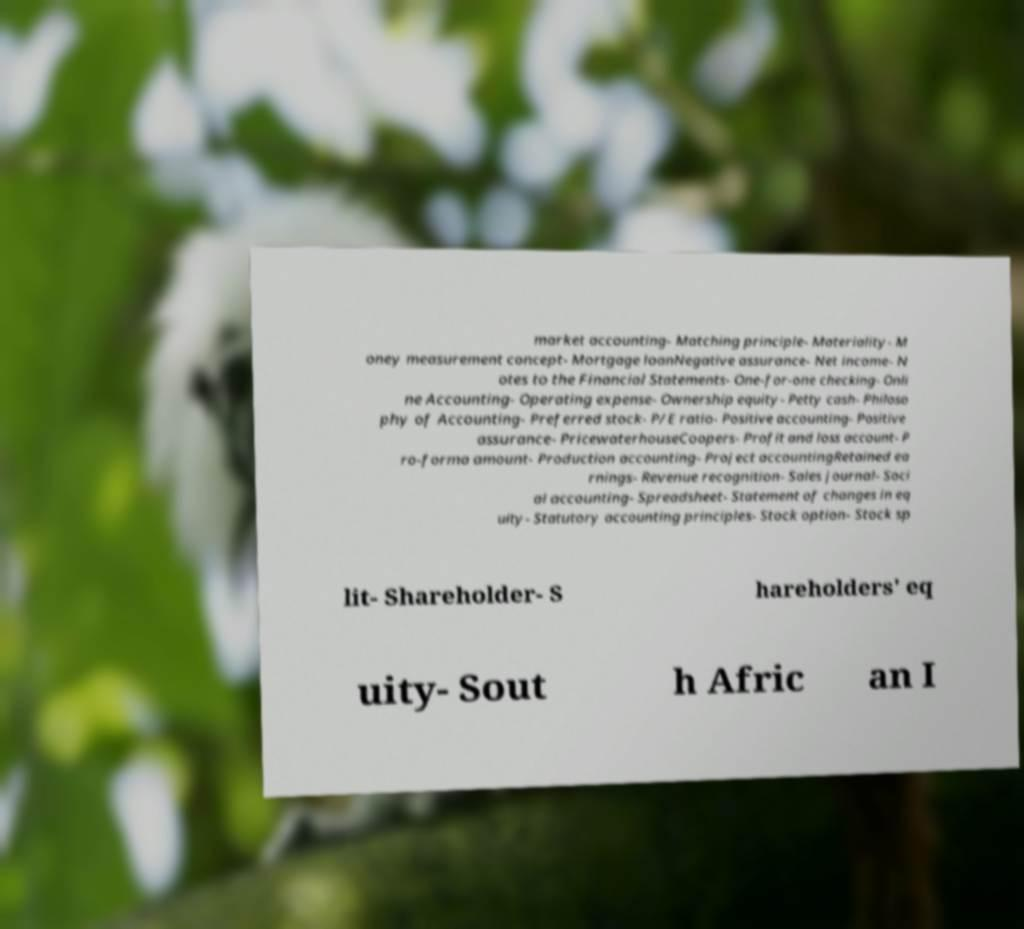I need the written content from this picture converted into text. Can you do that? market accounting- Matching principle- Materiality- M oney measurement concept- Mortgage loanNegative assurance- Net income- N otes to the Financial Statements- One-for-one checking- Onli ne Accounting- Operating expense- Ownership equity- Petty cash- Philoso phy of Accounting- Preferred stock- P/E ratio- Positive accounting- Positive assurance- PricewaterhouseCoopers- Profit and loss account- P ro-forma amount- Production accounting- Project accountingRetained ea rnings- Revenue recognition- Sales journal- Soci al accounting- Spreadsheet- Statement of changes in eq uity- Statutory accounting principles- Stock option- Stock sp lit- Shareholder- S hareholders' eq uity- Sout h Afric an I 